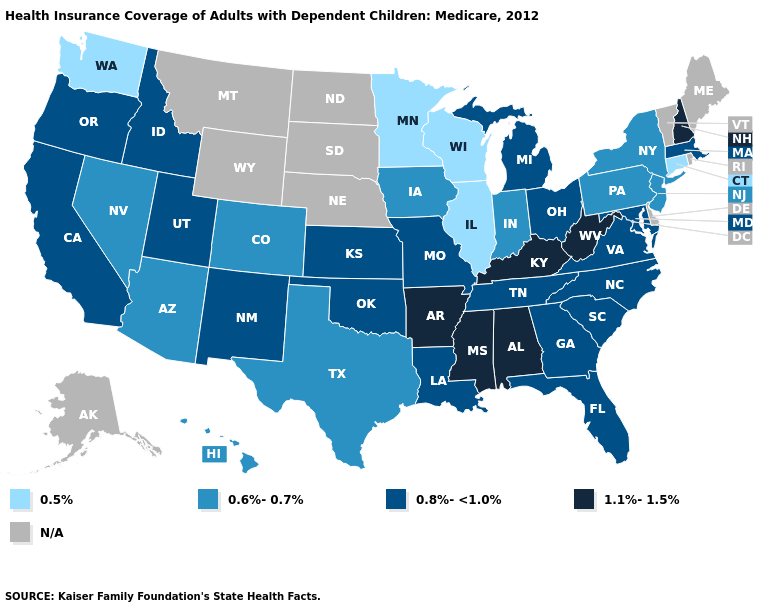What is the lowest value in the USA?
Quick response, please. 0.5%. Name the states that have a value in the range 0.5%?
Answer briefly. Connecticut, Illinois, Minnesota, Washington, Wisconsin. Does Connecticut have the lowest value in the USA?
Quick response, please. Yes. Which states hav the highest value in the West?
Short answer required. California, Idaho, New Mexico, Oregon, Utah. Among the states that border Indiana , does Kentucky have the highest value?
Quick response, please. Yes. What is the lowest value in the MidWest?
Give a very brief answer. 0.5%. Among the states that border Georgia , does Alabama have the lowest value?
Quick response, please. No. Name the states that have a value in the range 0.8%-<1.0%?
Be succinct. California, Florida, Georgia, Idaho, Kansas, Louisiana, Maryland, Massachusetts, Michigan, Missouri, New Mexico, North Carolina, Ohio, Oklahoma, Oregon, South Carolina, Tennessee, Utah, Virginia. Among the states that border Arizona , does Nevada have the lowest value?
Answer briefly. Yes. Name the states that have a value in the range 1.1%-1.5%?
Give a very brief answer. Alabama, Arkansas, Kentucky, Mississippi, New Hampshire, West Virginia. What is the value of Utah?
Quick response, please. 0.8%-<1.0%. What is the value of Louisiana?
Short answer required. 0.8%-<1.0%. What is the value of Virginia?
Concise answer only. 0.8%-<1.0%. What is the value of Indiana?
Short answer required. 0.6%-0.7%. 